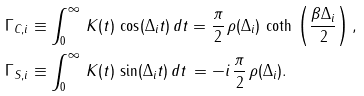Convert formula to latex. <formula><loc_0><loc_0><loc_500><loc_500>\Gamma _ { C , i } & \equiv \int _ { 0 } ^ { \infty } \, K ( t ) \, \cos ( \Delta _ { i } t ) \, d t = \frac { \pi } { 2 } \, \rho ( \Delta _ { i } ) \, \coth \, \left ( \frac { \beta \Delta _ { i } } { 2 } \right ) , \\ \Gamma _ { S , i } & \equiv \int _ { 0 } ^ { \infty } \, K ( t ) \, \sin ( \Delta _ { i } t ) \, d t \, = - i \, \frac { \pi } { 2 } \, \rho ( \Delta _ { i } ) .</formula> 